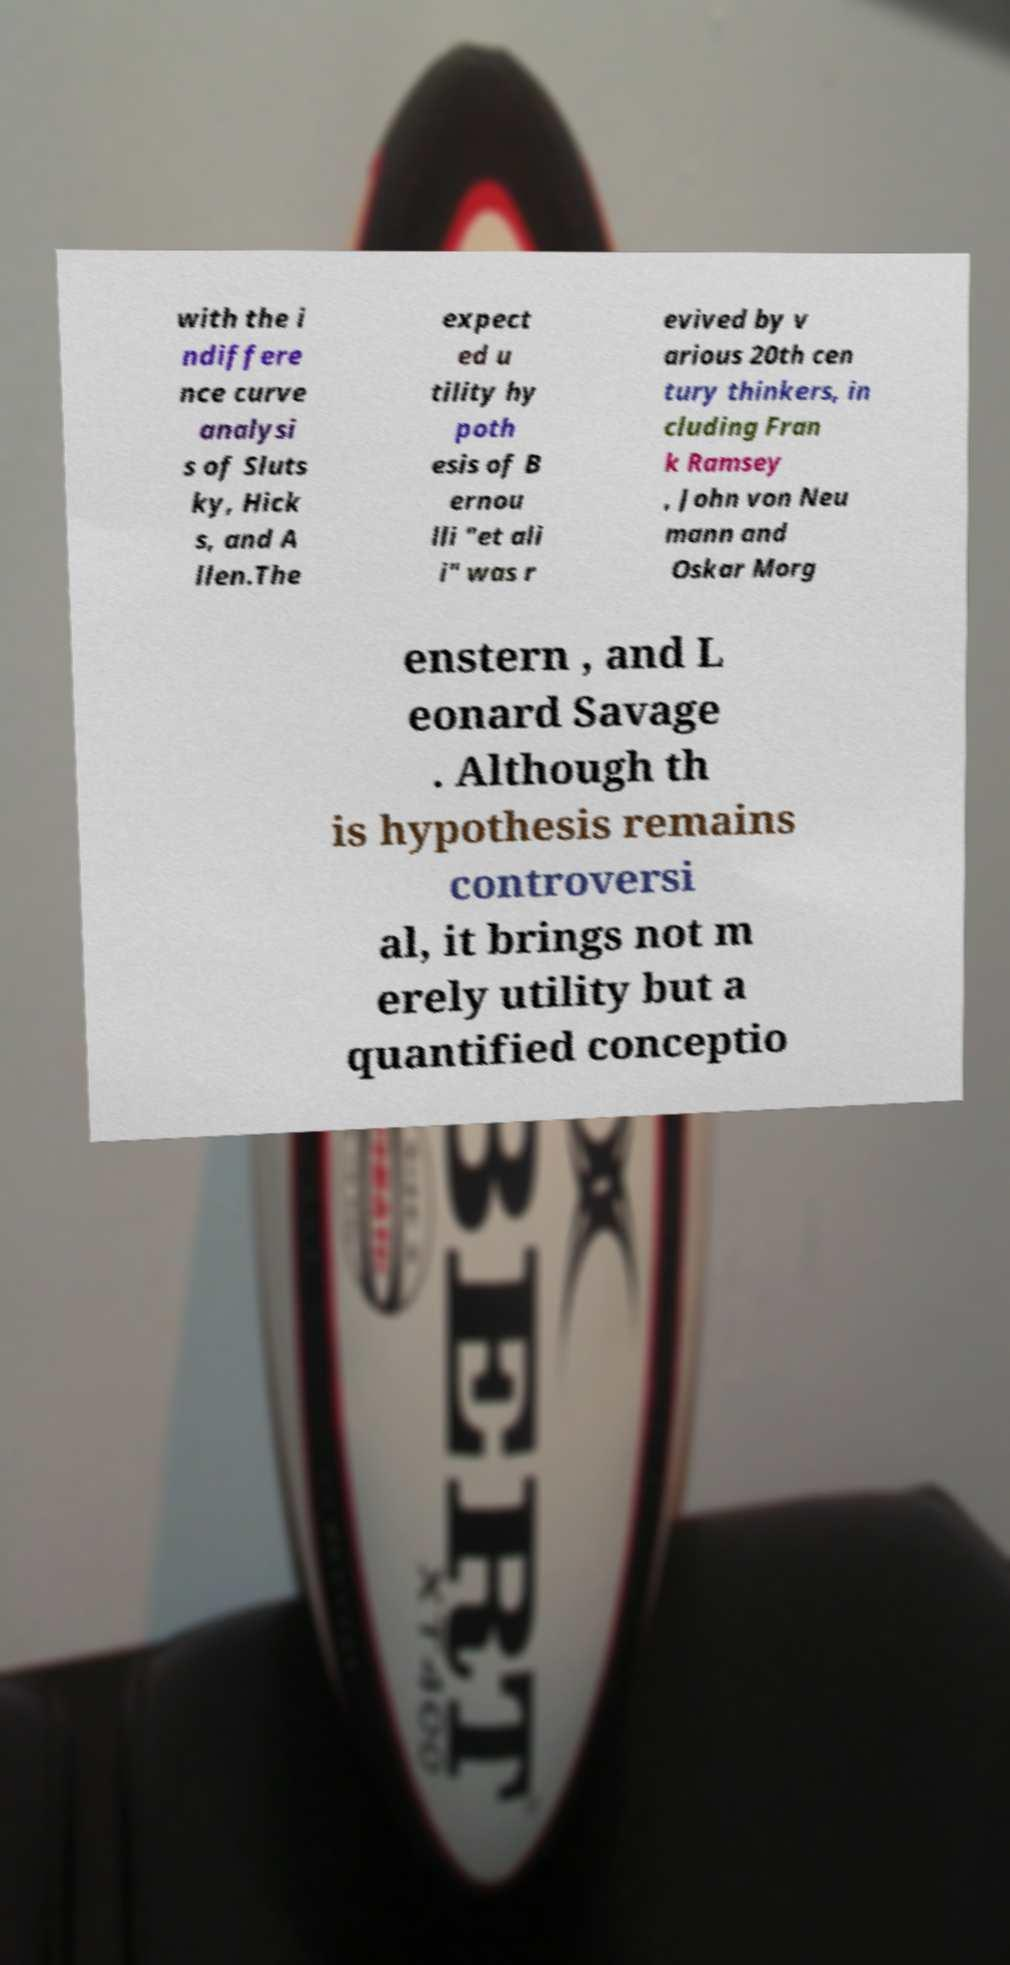Could you extract and type out the text from this image? with the i ndiffere nce curve analysi s of Sluts ky, Hick s, and A llen.The expect ed u tility hy poth esis of B ernou lli "et ali i" was r evived by v arious 20th cen tury thinkers, in cluding Fran k Ramsey , John von Neu mann and Oskar Morg enstern , and L eonard Savage . Although th is hypothesis remains controversi al, it brings not m erely utility but a quantified conceptio 